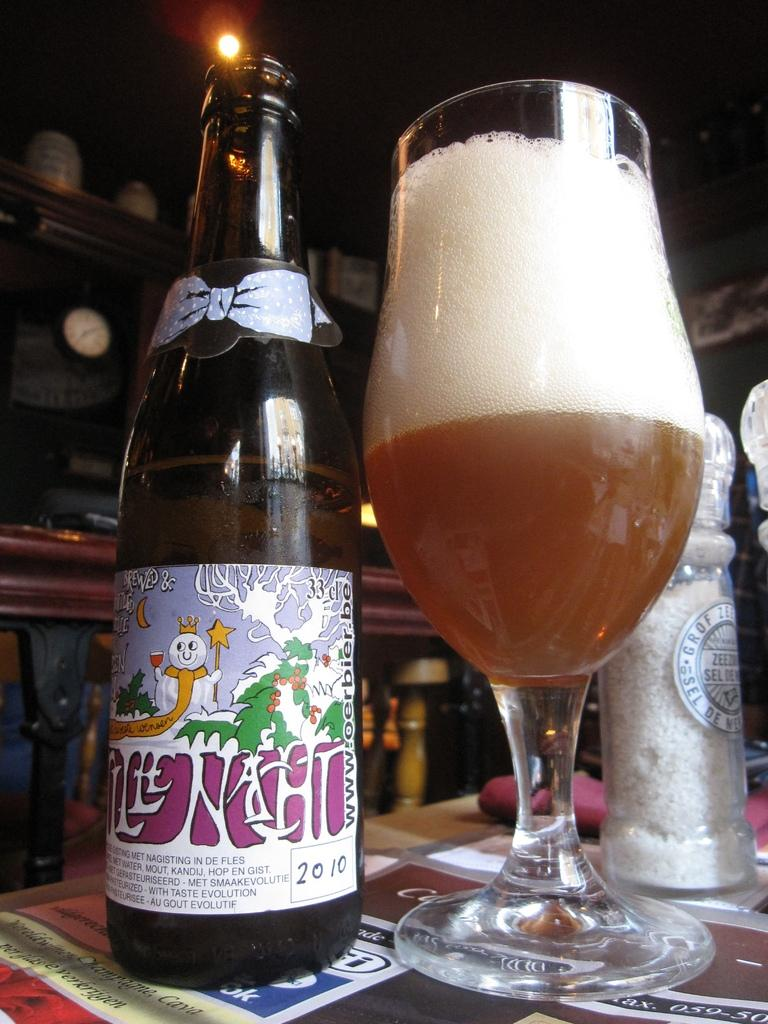<image>
Relay a brief, clear account of the picture shown. Bottle of beer from the year 2010 next to a cup of beer. 